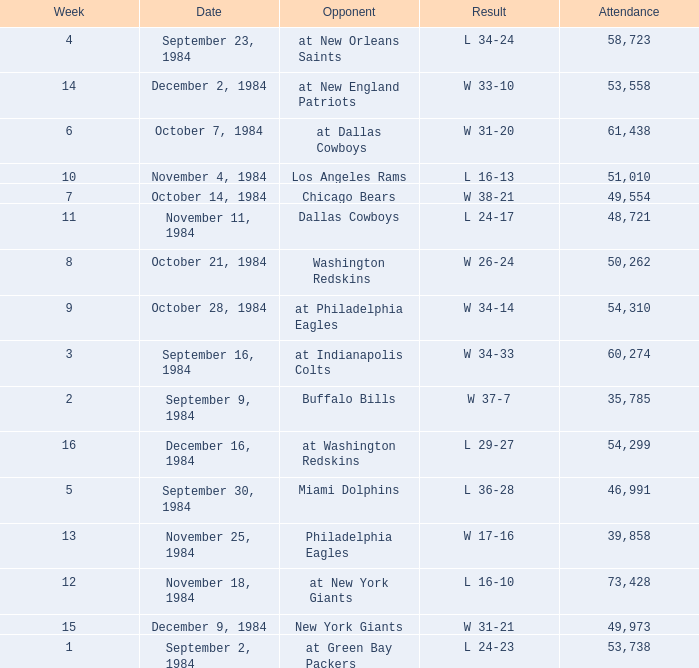What is the sum of attendance when the result was l 16-13? 51010.0. 